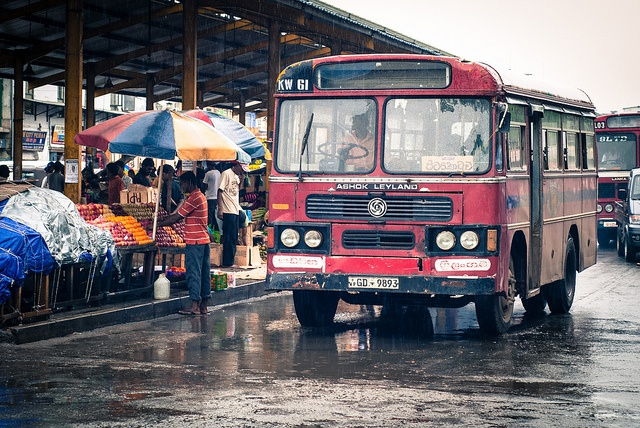Describe the objects in this image and their specific colors. I can see bus in black, lightgray, darkgray, and gray tones, umbrella in black, ivory, blue, orange, and gray tones, bus in black, gray, navy, and darkgray tones, people in black, navy, maroon, and blue tones, and car in black, gray, darkblue, and lightgray tones in this image. 